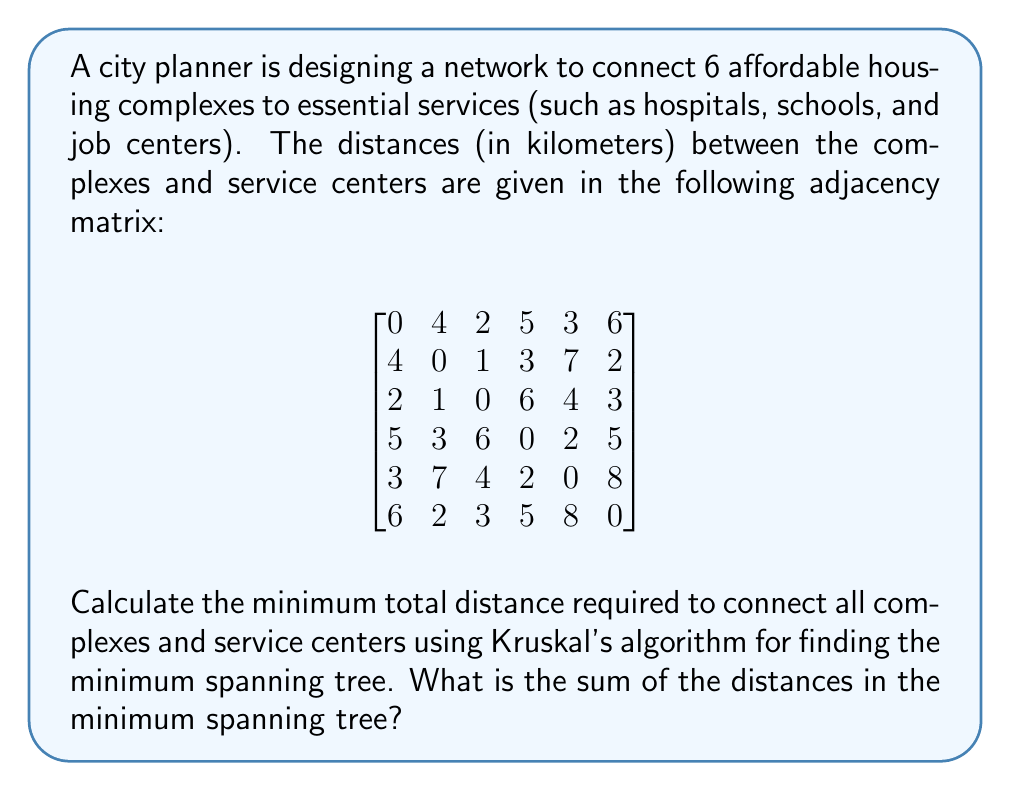What is the answer to this math problem? To solve this problem, we'll use Kruskal's algorithm to find the minimum spanning tree (MST) of the given graph. Here's a step-by-step explanation:

1. List all edges in ascending order of weight (distance):
   (2,3): 1 km
   (4,5): 2 km
   (1,3): 2 km
   (2,6): 2 km
   (1,5): 3 km
   (2,4): 3 km
   (3,6): 3 km
   (1,2): 4 km
   (3,5): 4 km
   (1,4): 5 km
   (4,6): 5 km
   (1,6): 6 km
   (2,5): 7 km
   (5,6): 8 km

2. Initialize a forest with each vertex in its own tree.

3. Iterate through the sorted edges:
   a. (2,3): 1 km - Add to MST
   b. (4,5): 2 km - Add to MST
   c. (1,3): 2 km - Add to MST
   d. (2,6): 2 km - Add to MST
   e. (1,5): 3 km - Add to MST (completes the tree)

4. The algorithm stops here as we have connected all 6 vertices with 5 edges, forming a tree.

5. Sum the distances of the edges in the MST:
   1 + 2 + 2 + 2 + 3 = 10 km

Therefore, the minimum total distance required to connect all complexes and service centers is 10 kilometers.

[asy]
unitsize(30);
pair[] vertices = {(0,0), (2,0), (1,1.732), (-1,1.732), (-2,0), (-1,-1.732)};
for(int i = 0; i < 6; ++i) {
  dot(vertices[i]);
  label("" + (i+1), vertices[i], align=2*vertices[i]);
}
draw(vertices[1]--vertices[2], red+1);
draw(vertices[3]--vertices[4], red+1);
draw(vertices[0]--vertices[2], red+1);
draw(vertices[1]--vertices[5], red+1);
draw(vertices[0]--vertices[4], red+1);
[/asy]
Answer: The sum of the distances in the minimum spanning tree is 10 kilometers. 